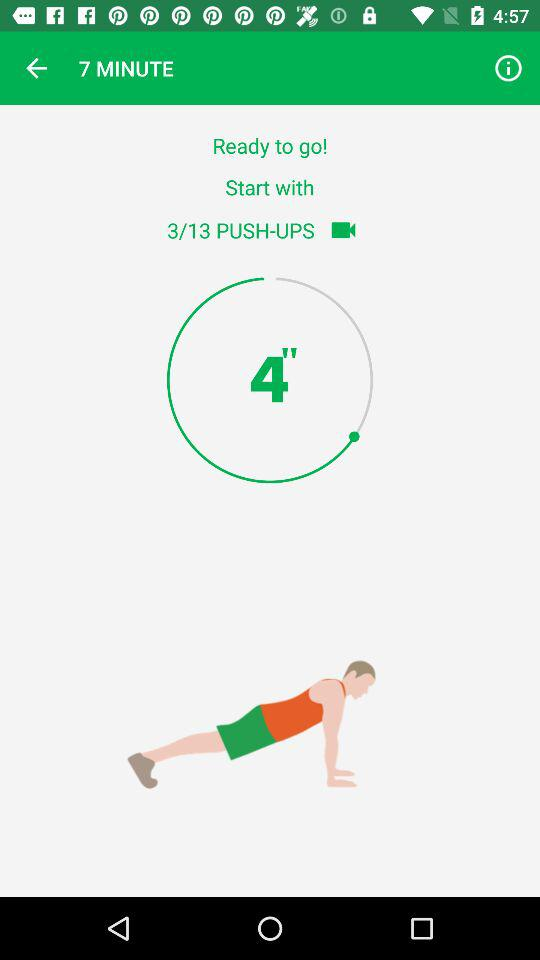How many minutes are shown on the screen?
When the provided information is insufficient, respond with <no answer>. <no answer> 